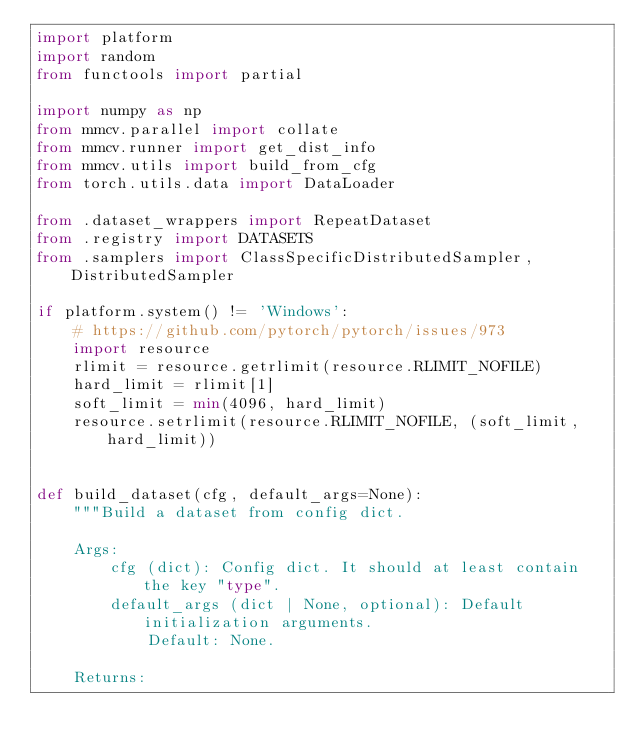Convert code to text. <code><loc_0><loc_0><loc_500><loc_500><_Python_>import platform
import random
from functools import partial

import numpy as np
from mmcv.parallel import collate
from mmcv.runner import get_dist_info
from mmcv.utils import build_from_cfg
from torch.utils.data import DataLoader

from .dataset_wrappers import RepeatDataset
from .registry import DATASETS
from .samplers import ClassSpecificDistributedSampler, DistributedSampler

if platform.system() != 'Windows':
    # https://github.com/pytorch/pytorch/issues/973
    import resource
    rlimit = resource.getrlimit(resource.RLIMIT_NOFILE)
    hard_limit = rlimit[1]
    soft_limit = min(4096, hard_limit)
    resource.setrlimit(resource.RLIMIT_NOFILE, (soft_limit, hard_limit))


def build_dataset(cfg, default_args=None):
    """Build a dataset from config dict.

    Args:
        cfg (dict): Config dict. It should at least contain the key "type".
        default_args (dict | None, optional): Default initialization arguments.
            Default: None.

    Returns:</code> 